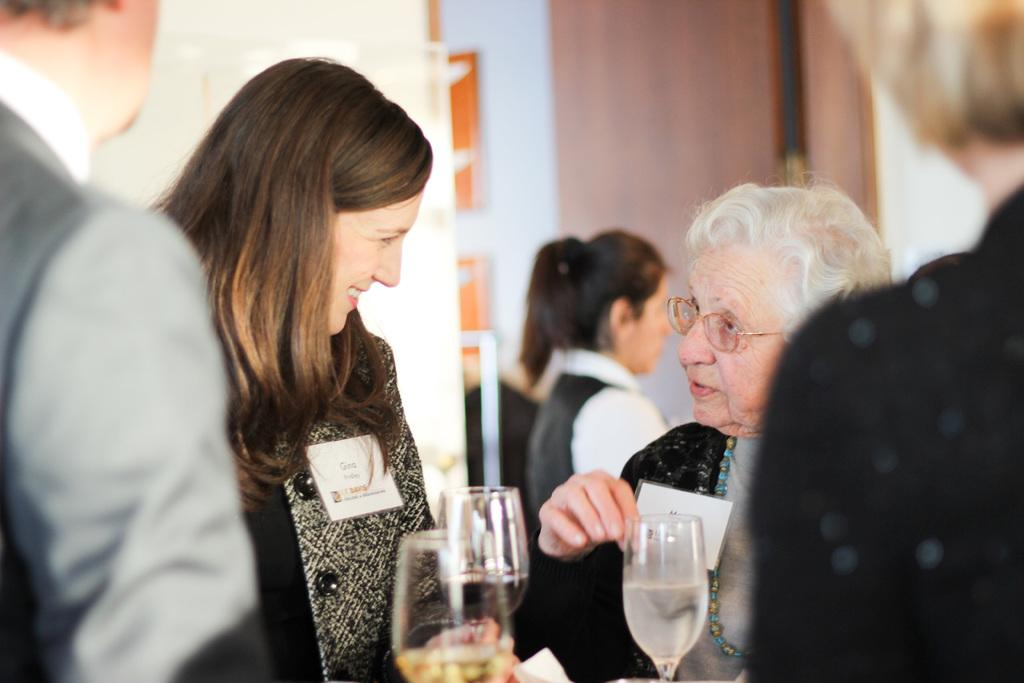Who is the main subject in the image? There is a woman standing in the middle of the image. What are the people on the right side of the image doing? On the right side of the image, there are two people standing and watching. How many people are on the left side of the image? On the left side of the image, there are two people standing. How many laborers are present in the image? There is no mention of laborers in the image, so it is impossible to determine their presence or number. 